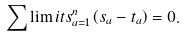Convert formula to latex. <formula><loc_0><loc_0><loc_500><loc_500>\sum \lim i t s _ { a = 1 } ^ { n } \left ( s _ { a } - t _ { a } \right ) = 0 .</formula> 